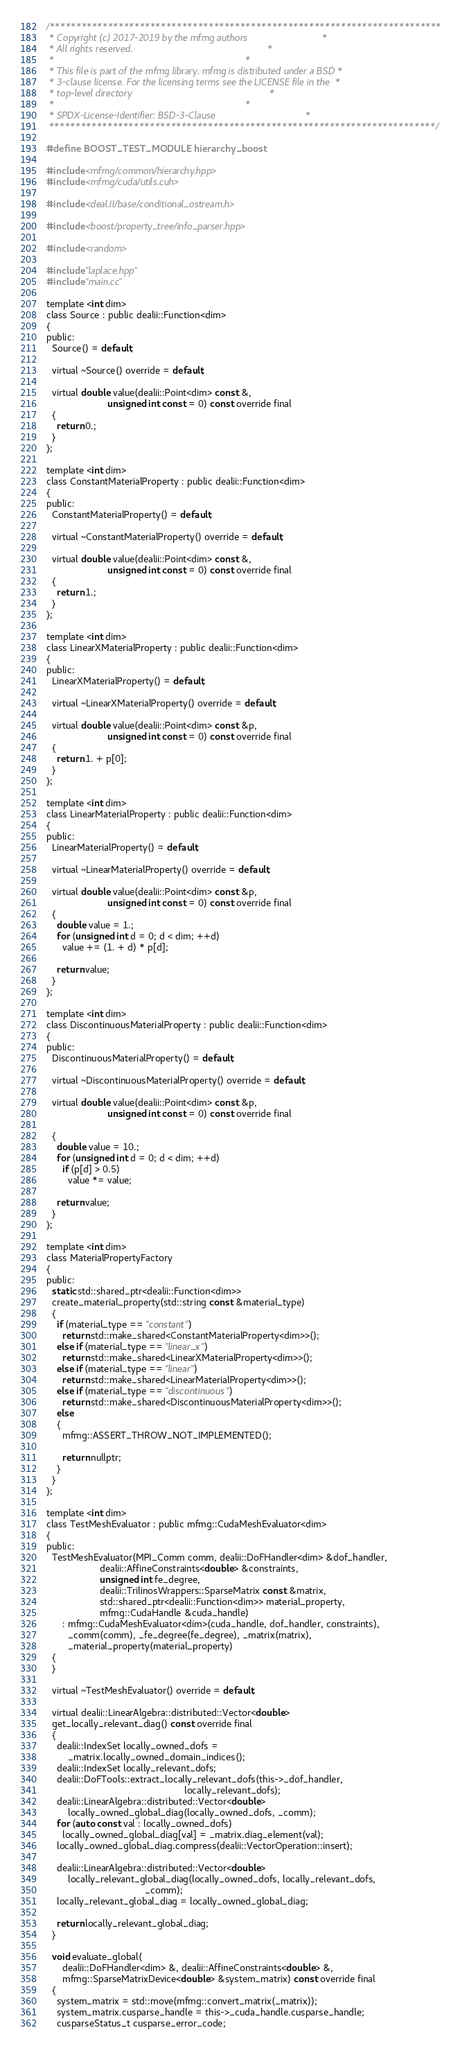<code> <loc_0><loc_0><loc_500><loc_500><_Cuda_>/**************************************************************************
 * Copyright (c) 2017-2019 by the mfmg authors                            *
 * All rights reserved.                                                   *
 *                                                                        *
 * This file is part of the mfmg library. mfmg is distributed under a BSD *
 * 3-clause license. For the licensing terms see the LICENSE file in the  *
 * top-level directory                                                    *
 *                                                                        *
 * SPDX-License-Identifier: BSD-3-Clause                                  *
 *************************************************************************/

#define BOOST_TEST_MODULE hierarchy_boost

#include <mfmg/common/hierarchy.hpp>
#include <mfmg/cuda/utils.cuh>

#include <deal.II/base/conditional_ostream.h>

#include <boost/property_tree/info_parser.hpp>

#include <random>

#include "laplace.hpp"
#include "main.cc"

template <int dim>
class Source : public dealii::Function<dim>
{
public:
  Source() = default;

  virtual ~Source() override = default;

  virtual double value(dealii::Point<dim> const &,
                       unsigned int const = 0) const override final
  {
    return 0.;
  }
};

template <int dim>
class ConstantMaterialProperty : public dealii::Function<dim>
{
public:
  ConstantMaterialProperty() = default;

  virtual ~ConstantMaterialProperty() override = default;

  virtual double value(dealii::Point<dim> const &,
                       unsigned int const = 0) const override final
  {
    return 1.;
  }
};

template <int dim>
class LinearXMaterialProperty : public dealii::Function<dim>
{
public:
  LinearXMaterialProperty() = default;

  virtual ~LinearXMaterialProperty() override = default;

  virtual double value(dealii::Point<dim> const &p,
                       unsigned int const = 0) const override final
  {
    return 1. + p[0];
  }
};

template <int dim>
class LinearMaterialProperty : public dealii::Function<dim>
{
public:
  LinearMaterialProperty() = default;

  virtual ~LinearMaterialProperty() override = default;

  virtual double value(dealii::Point<dim> const &p,
                       unsigned int const = 0) const override final
  {
    double value = 1.;
    for (unsigned int d = 0; d < dim; ++d)
      value += (1. + d) * p[d];

    return value;
  }
};

template <int dim>
class DiscontinuousMaterialProperty : public dealii::Function<dim>
{
public:
  DiscontinuousMaterialProperty() = default;

  virtual ~DiscontinuousMaterialProperty() override = default;

  virtual double value(dealii::Point<dim> const &p,
                       unsigned int const = 0) const override final

  {
    double value = 10.;
    for (unsigned int d = 0; d < dim; ++d)
      if (p[d] > 0.5)
        value *= value;

    return value;
  }
};

template <int dim>
class MaterialPropertyFactory
{
public:
  static std::shared_ptr<dealii::Function<dim>>
  create_material_property(std::string const &material_type)
  {
    if (material_type == "constant")
      return std::make_shared<ConstantMaterialProperty<dim>>();
    else if (material_type == "linear_x")
      return std::make_shared<LinearXMaterialProperty<dim>>();
    else if (material_type == "linear")
      return std::make_shared<LinearMaterialProperty<dim>>();
    else if (material_type == "discontinuous")
      return std::make_shared<DiscontinuousMaterialProperty<dim>>();
    else
    {
      mfmg::ASSERT_THROW_NOT_IMPLEMENTED();

      return nullptr;
    }
  }
};

template <int dim>
class TestMeshEvaluator : public mfmg::CudaMeshEvaluator<dim>
{
public:
  TestMeshEvaluator(MPI_Comm comm, dealii::DoFHandler<dim> &dof_handler,
                    dealii::AffineConstraints<double> &constraints,
                    unsigned int fe_degree,
                    dealii::TrilinosWrappers::SparseMatrix const &matrix,
                    std::shared_ptr<dealii::Function<dim>> material_property,
                    mfmg::CudaHandle &cuda_handle)
      : mfmg::CudaMeshEvaluator<dim>(cuda_handle, dof_handler, constraints),
        _comm(comm), _fe_degree(fe_degree), _matrix(matrix),
        _material_property(material_property)
  {
  }

  virtual ~TestMeshEvaluator() override = default;

  virtual dealii::LinearAlgebra::distributed::Vector<double>
  get_locally_relevant_diag() const override final
  {
    dealii::IndexSet locally_owned_dofs =
        _matrix.locally_owned_domain_indices();
    dealii::IndexSet locally_relevant_dofs;
    dealii::DoFTools::extract_locally_relevant_dofs(this->_dof_handler,
                                                    locally_relevant_dofs);
    dealii::LinearAlgebra::distributed::Vector<double>
        locally_owned_global_diag(locally_owned_dofs, _comm);
    for (auto const val : locally_owned_dofs)
      locally_owned_global_diag[val] = _matrix.diag_element(val);
    locally_owned_global_diag.compress(dealii::VectorOperation::insert);

    dealii::LinearAlgebra::distributed::Vector<double>
        locally_relevant_global_diag(locally_owned_dofs, locally_relevant_dofs,
                                     _comm);
    locally_relevant_global_diag = locally_owned_global_diag;

    return locally_relevant_global_diag;
  }

  void evaluate_global(
      dealii::DoFHandler<dim> &, dealii::AffineConstraints<double> &,
      mfmg::SparseMatrixDevice<double> &system_matrix) const override final
  {
    system_matrix = std::move(mfmg::convert_matrix(_matrix));
    system_matrix.cusparse_handle = this->_cuda_handle.cusparse_handle;
    cusparseStatus_t cusparse_error_code;</code> 